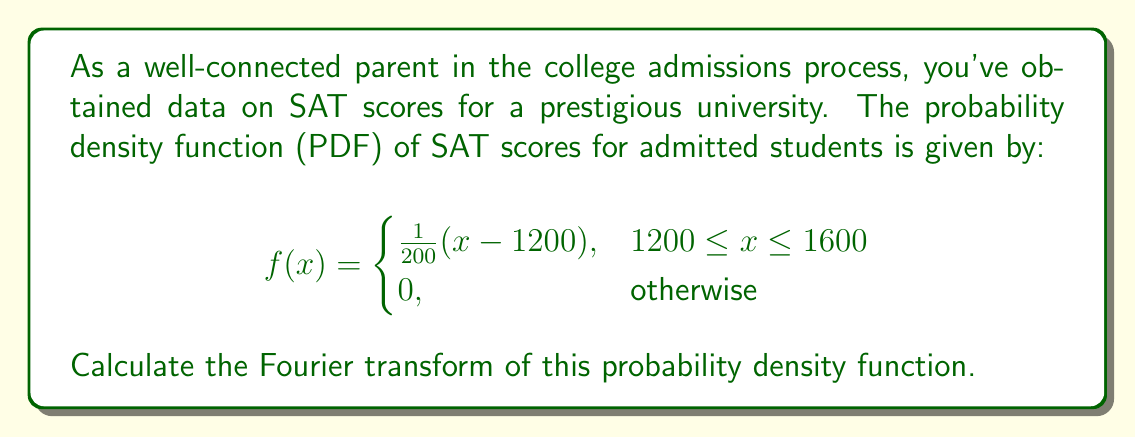Provide a solution to this math problem. To calculate the Fourier transform of the given probability density function, we'll follow these steps:

1) The Fourier transform of a function $f(x)$ is defined as:

   $$F(\omega) = \int_{-\infty}^{\infty} f(x) e^{-i\omega x} dx$$

2) In our case, the function is only non-zero between 1200 and 1600, so we can adjust our limits:

   $$F(\omega) = \int_{1200}^{1600} \frac{1}{200}(x - 1200) e^{-i\omega x} dx$$

3) Let's solve this integral step by step:

   $$F(\omega) = \frac{1}{200} \int_{1200}^{1600} (x - 1200) e^{-i\omega x} dx$$

4) We can use integration by parts. Let $u = x - 1200$ and $dv = e^{-i\omega x} dx$. Then $du = dx$ and $v = -\frac{1}{i\omega}e^{-i\omega x}$:

   $$F(\omega) = \frac{1}{200} \left[ -\frac{1}{i\omega}(x-1200)e^{-i\omega x} \right]_{1200}^{1600} + \frac{1}{200i\omega} \int_{1200}^{1600} e^{-i\omega x} dx$$

5) Evaluating the first term:

   $$F(\omega) = \frac{1}{200} \left( -\frac{400}{i\omega}e^{-1600i\omega} \right) + \frac{1}{200i\omega} \left[ -\frac{1}{i\omega}e^{-i\omega x} \right]_{1200}^{1600}$$

6) Simplifying:

   $$F(\omega) = -\frac{2}{i\omega}e^{-1600i\omega} + \frac{1}{200\omega^2} \left( e^{-1600i\omega} - e^{-1200i\omega} \right)$$

7) Combining terms:

   $$F(\omega) = \frac{e^{-1600i\omega}}{i\omega} \left( -2 + \frac{i}{200\omega} \right) - \frac{e^{-1200i\omega}}{200\omega^2}$$

This is the Fourier transform of the given probability density function.
Answer: $$F(\omega) = \frac{e^{-1600i\omega}}{i\omega} \left( -2 + \frac{i}{200\omega} \right) - \frac{e^{-1200i\omega}}{200\omega^2}$$ 